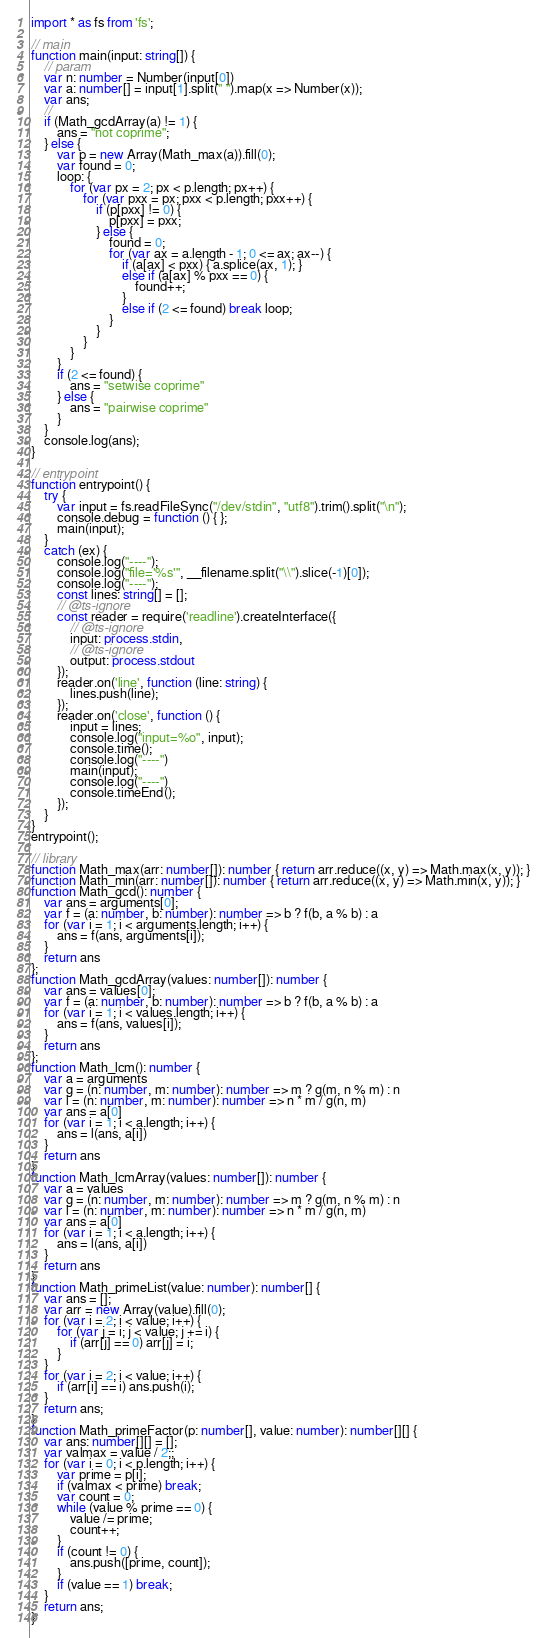Convert code to text. <code><loc_0><loc_0><loc_500><loc_500><_TypeScript_>import * as fs from 'fs';

// main
function main(input: string[]) {
    // param
    var n: number = Number(input[0])
    var a: number[] = input[1].split(" ").map(x => Number(x));
    var ans;
    // 
    if (Math_gcdArray(a) != 1) {
        ans = "not coprime";
    } else {
        var p = new Array(Math_max(a)).fill(0);
        var found = 0;
        loop: {
            for (var px = 2; px < p.length; px++) {
                for (var pxx = px; pxx < p.length; pxx++) {
                    if (p[pxx] != 0) {
                        p[pxx] = pxx;
                    } else {
                        found = 0;
                        for (var ax = a.length - 1; 0 <= ax; ax--) {
                            if (a[ax] < pxx) { a.splice(ax, 1); }
                            else if (a[ax] % pxx == 0) {
                                found++;
                            }
                            else if (2 <= found) break loop;
                        }
                    }
                }
            }
        }
        if (2 <= found) {
            ans = "setwise coprime"
        } else {
            ans = "pairwise coprime"
        }
    }
    console.log(ans);
}

// entrypoint
function entrypoint() {
    try {
        var input = fs.readFileSync("/dev/stdin", "utf8").trim().split("\n");
        console.debug = function () { };
        main(input);
    }
    catch (ex) {
        console.log("----");
        console.log("file='%s'", __filename.split("\\").slice(-1)[0]);
        console.log("----");
        const lines: string[] = [];
        // @ts-ignore
        const reader = require('readline').createInterface({
            // @ts-ignore
            input: process.stdin,
            // @ts-ignore
            output: process.stdout
        });
        reader.on('line', function (line: string) {
            lines.push(line);
        });
        reader.on('close', function () {
            input = lines;
            console.log("input=%o", input);
            console.time();
            console.log("----")
            main(input);
            console.log("----")
            console.timeEnd();
        });
    }
}
entrypoint();

// library
function Math_max(arr: number[]): number { return arr.reduce((x, y) => Math.max(x, y)); }
function Math_min(arr: number[]): number { return arr.reduce((x, y) => Math.min(x, y)); }
function Math_gcd(): number {
    var ans = arguments[0];
    var f = (a: number, b: number): number => b ? f(b, a % b) : a
    for (var i = 1; i < arguments.length; i++) {
        ans = f(ans, arguments[i]);
    }
    return ans
};
function Math_gcdArray(values: number[]): number {
    var ans = values[0];
    var f = (a: number, b: number): number => b ? f(b, a % b) : a
    for (var i = 1; i < values.length; i++) {
        ans = f(ans, values[i]);
    }
    return ans
};
function Math_lcm(): number {
    var a = arguments
    var g = (n: number, m: number): number => m ? g(m, n % m) : n
    var l = (n: number, m: number): number => n * m / g(n, m)
    var ans = a[0]
    for (var i = 1; i < a.length; i++) {
        ans = l(ans, a[i])
    }
    return ans
}
function Math_lcmArray(values: number[]): number {
    var a = values
    var g = (n: number, m: number): number => m ? g(m, n % m) : n
    var l = (n: number, m: number): number => n * m / g(n, m)
    var ans = a[0]
    for (var i = 1; i < a.length; i++) {
        ans = l(ans, a[i])
    }
    return ans
}
function Math_primeList(value: number): number[] {
    var ans = [];
    var arr = new Array(value).fill(0);
    for (var i = 2; i < value; i++) {
        for (var j = i; j < value; j += i) {
            if (arr[j] == 0) arr[j] = i;
        }
    }
    for (var i = 2; i < value; i++) {
        if (arr[i] == i) ans.push(i);
    }
    return ans;
}
function Math_primeFactor(p: number[], value: number): number[][] {
    var ans: number[][] = [];
    var valmax = value / 2;;
    for (var i = 0; i < p.length; i++) {
        var prime = p[i];
        if (valmax < prime) break;
        var count = 0;
        while (value % prime == 0) {
            value /= prime;
            count++;
        }
        if (count != 0) {
            ans.push([prime, count]);
        }
        if (value == 1) break;
    }
    return ans;
}
</code> 